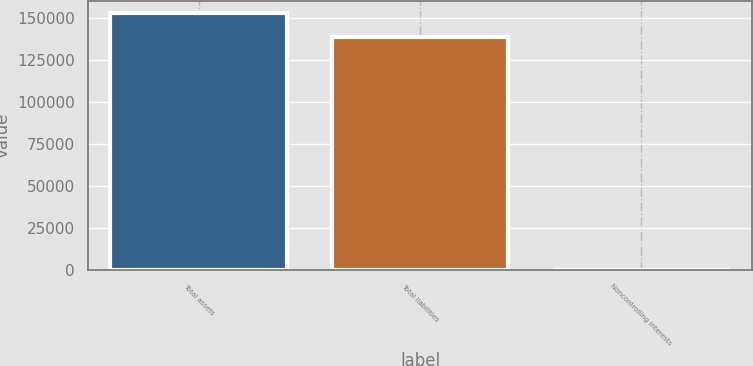Convert chart to OTSL. <chart><loc_0><loc_0><loc_500><loc_500><bar_chart><fcel>Total assets<fcel>Total liabilities<fcel>Noncontrolling interests<nl><fcel>152901<fcel>138742<fcel>41<nl></chart> 